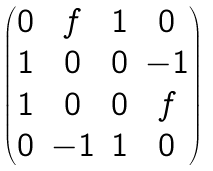<formula> <loc_0><loc_0><loc_500><loc_500>\begin{pmatrix} 0 & f & 1 & 0 \\ 1 & 0 & 0 & - 1 \\ 1 & 0 & 0 & f \\ 0 & - 1 & 1 & 0 \end{pmatrix}</formula> 